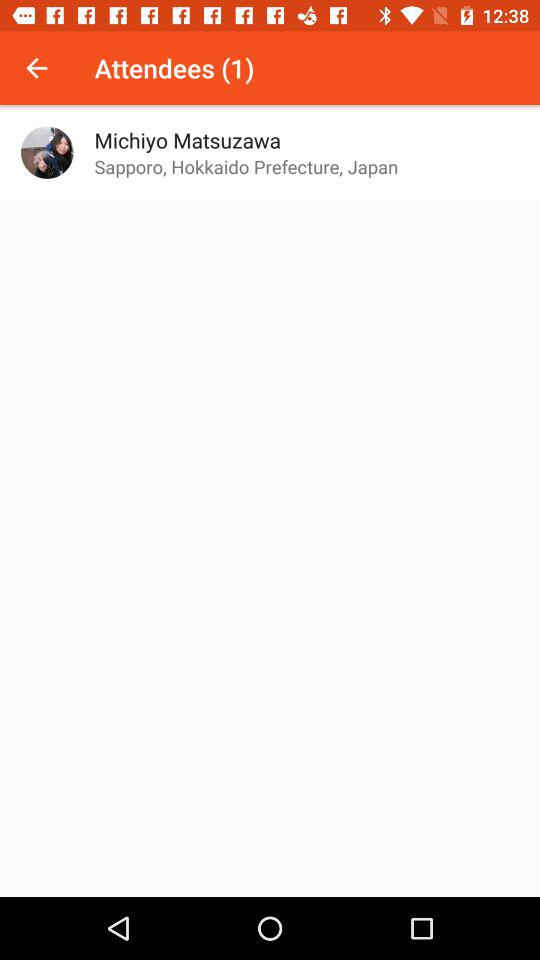What is the number of attendees? The number of attendees is 1. 